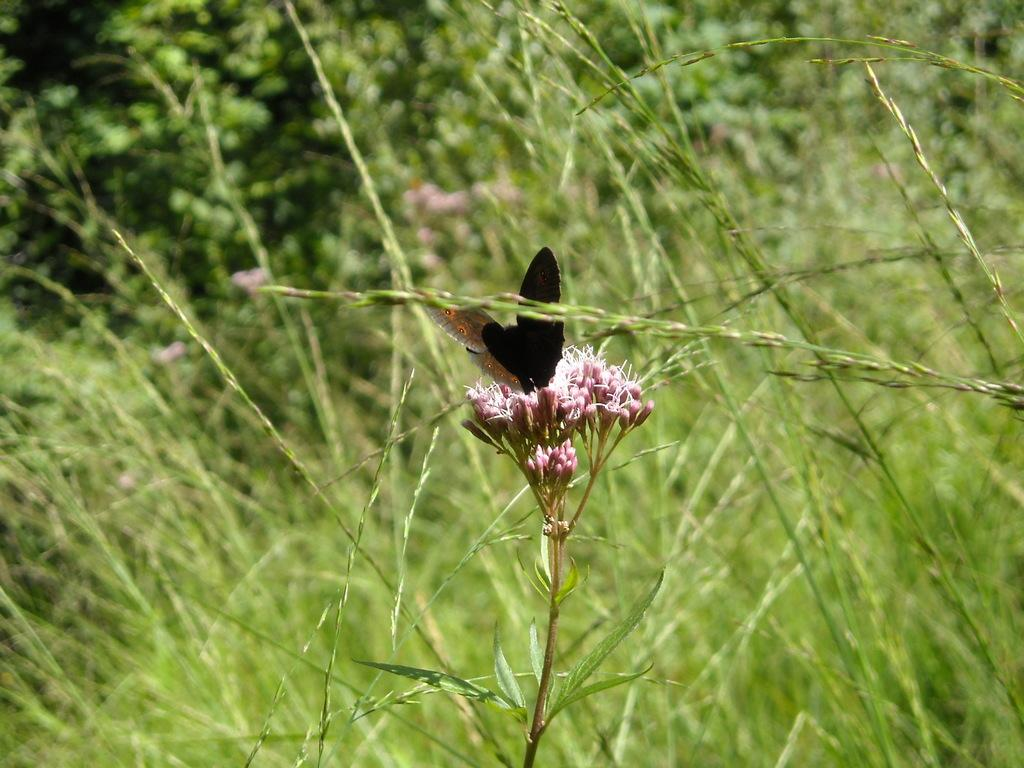What type of plant is featured in the image? There is a plant with buds in the image. What is on the plant? There is a butterfly on the plant. What can be seen in the background of the image? Grass and other plants are present in the background of the image. What type of flame can be seen on the plant in the image? There is no flame present on the plant in the image; it features a butterfly instead. 